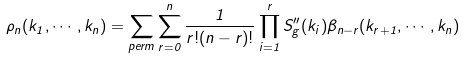Convert formula to latex. <formula><loc_0><loc_0><loc_500><loc_500>\rho _ { n } ( k _ { 1 } , \cdots , k _ { n } ) = \sum _ { p e r m } \sum _ { r = 0 } ^ { n } \frac { 1 } { r ! ( n - r ) ! } \prod _ { i = 1 } ^ { r } S ^ { \prime \prime } _ { g } ( k _ { i } ) \beta _ { n - r } ( k _ { r + 1 } , \cdots , k _ { n } )</formula> 